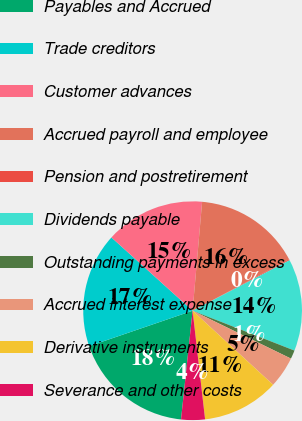<chart> <loc_0><loc_0><loc_500><loc_500><pie_chart><fcel>Payables and Accrued<fcel>Trade creditors<fcel>Customer advances<fcel>Accrued payroll and employee<fcel>Pension and postretirement<fcel>Dividends payable<fcel>Outstanding payments in excess<fcel>Accrued interest expense<fcel>Derivative instruments<fcel>Severance and other costs<nl><fcel>18.06%<fcel>16.94%<fcel>14.7%<fcel>15.82%<fcel>0.15%<fcel>13.58%<fcel>1.27%<fcel>4.63%<fcel>11.34%<fcel>3.51%<nl></chart> 